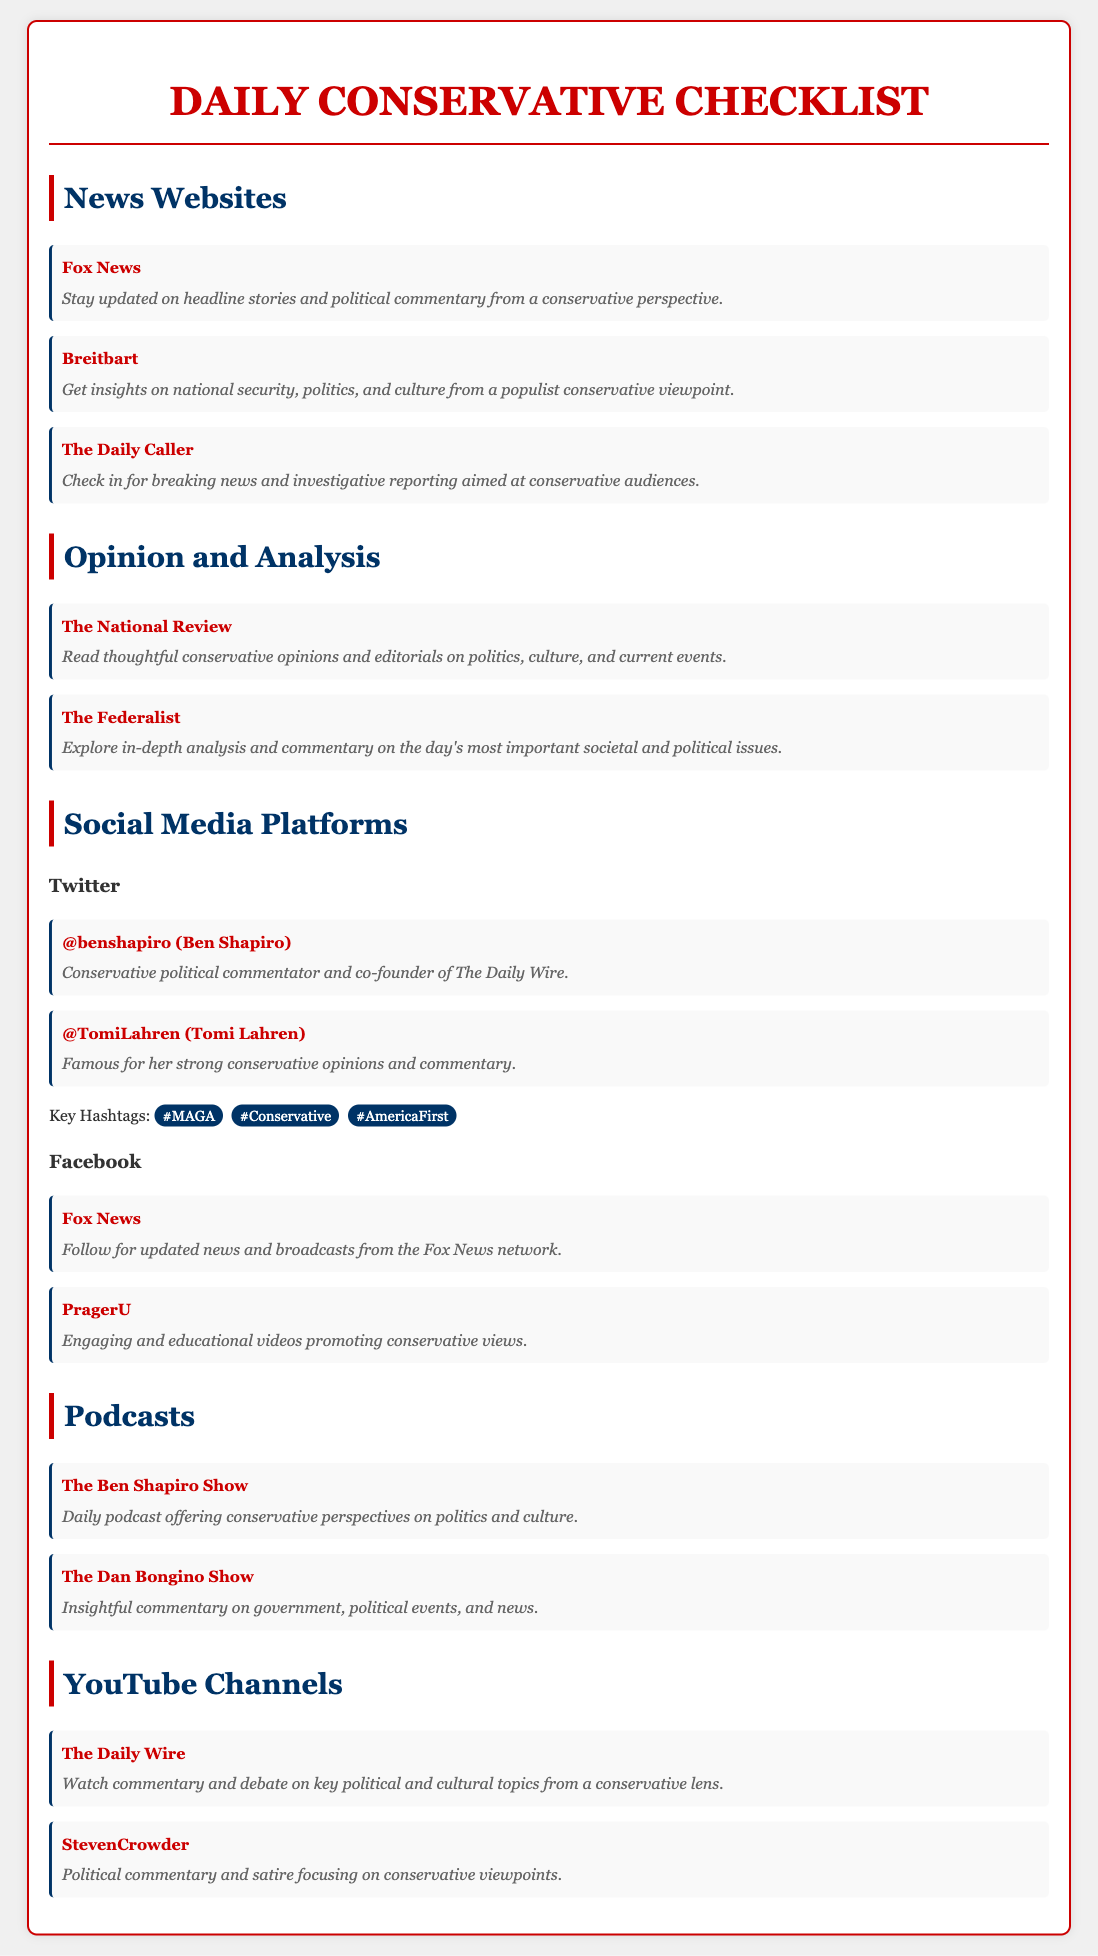what is the title of the checklist? The title is prominently displayed at the top of the document, indicating the purpose of the content.
Answer: Daily Conservative Checklist how many news websites are listed? The document provides a count of the news websites included in the section, which is three.
Answer: 3 who hosts "The Ben Shapiro Show"? This information can be found in the podcast section where the host's name is mentioned.
Answer: Ben Shapiro which social media platform features Tomi Lahren? The section for social media platforms specifies where she can be found.
Answer: Twitter what type of content does PragerU produce? The description in the Facebook section tells us the nature of PragerU's content.
Answer: Educational videos name one key hashtag mentioned in the document. The document lists key hashtags to follow for conservative views.
Answer: #MAGA how many podcasts are listed? The total number of podcasts provided in the checklist is straightforward from the section headings.
Answer: 2 which website focuses on populist conservative viewpoints? The document specifically points out the focus of this particular news site in its description.
Answer: Breitbart who is the political commentator behind the YouTube channel "StevenCrowder"? The description in the YouTube Channels section names the commentator.
Answer: Steven Crowder 